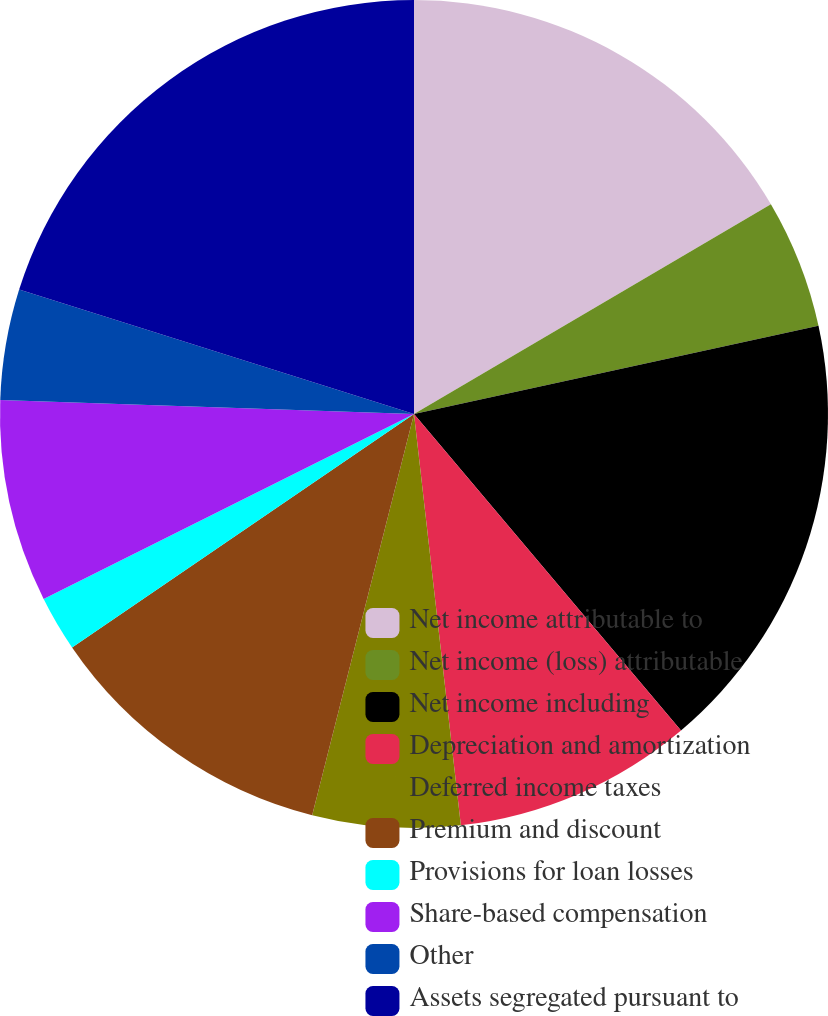Convert chart to OTSL. <chart><loc_0><loc_0><loc_500><loc_500><pie_chart><fcel>Net income attributable to<fcel>Net income (loss) attributable<fcel>Net income including<fcel>Depreciation and amortization<fcel>Deferred income taxes<fcel>Premium and discount<fcel>Provisions for loan losses<fcel>Share-based compensation<fcel>Other<fcel>Assets segregated pursuant to<nl><fcel>16.54%<fcel>5.04%<fcel>17.26%<fcel>9.35%<fcel>5.76%<fcel>11.51%<fcel>2.16%<fcel>7.91%<fcel>4.32%<fcel>20.14%<nl></chart> 